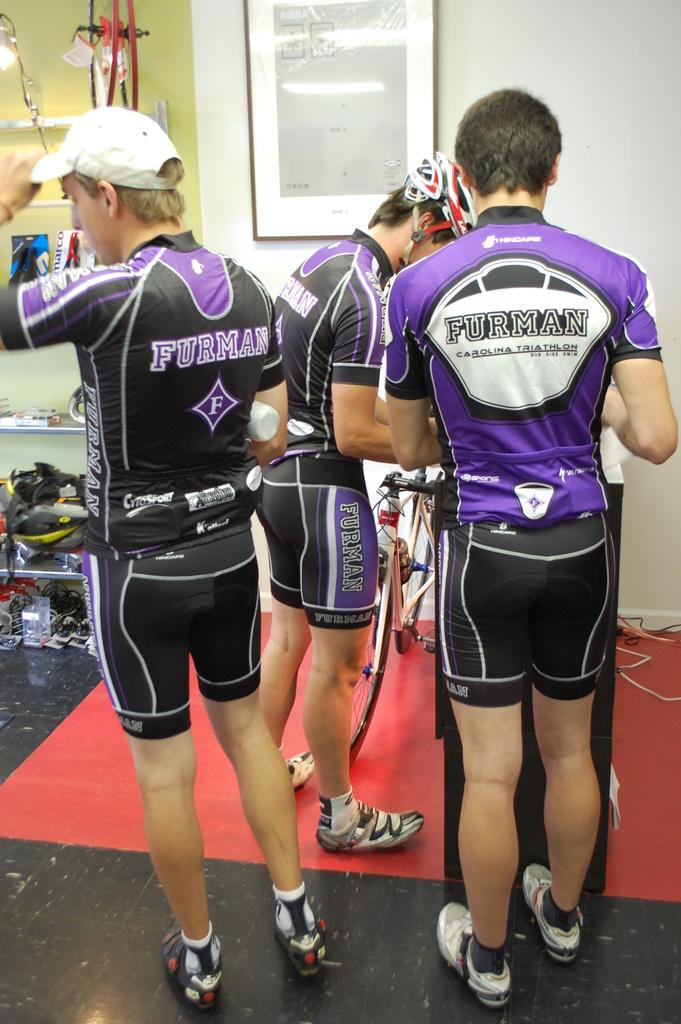<image>
Present a compact description of the photo's key features. Three men are wearing Furman Carolina Triathlon clothing. 